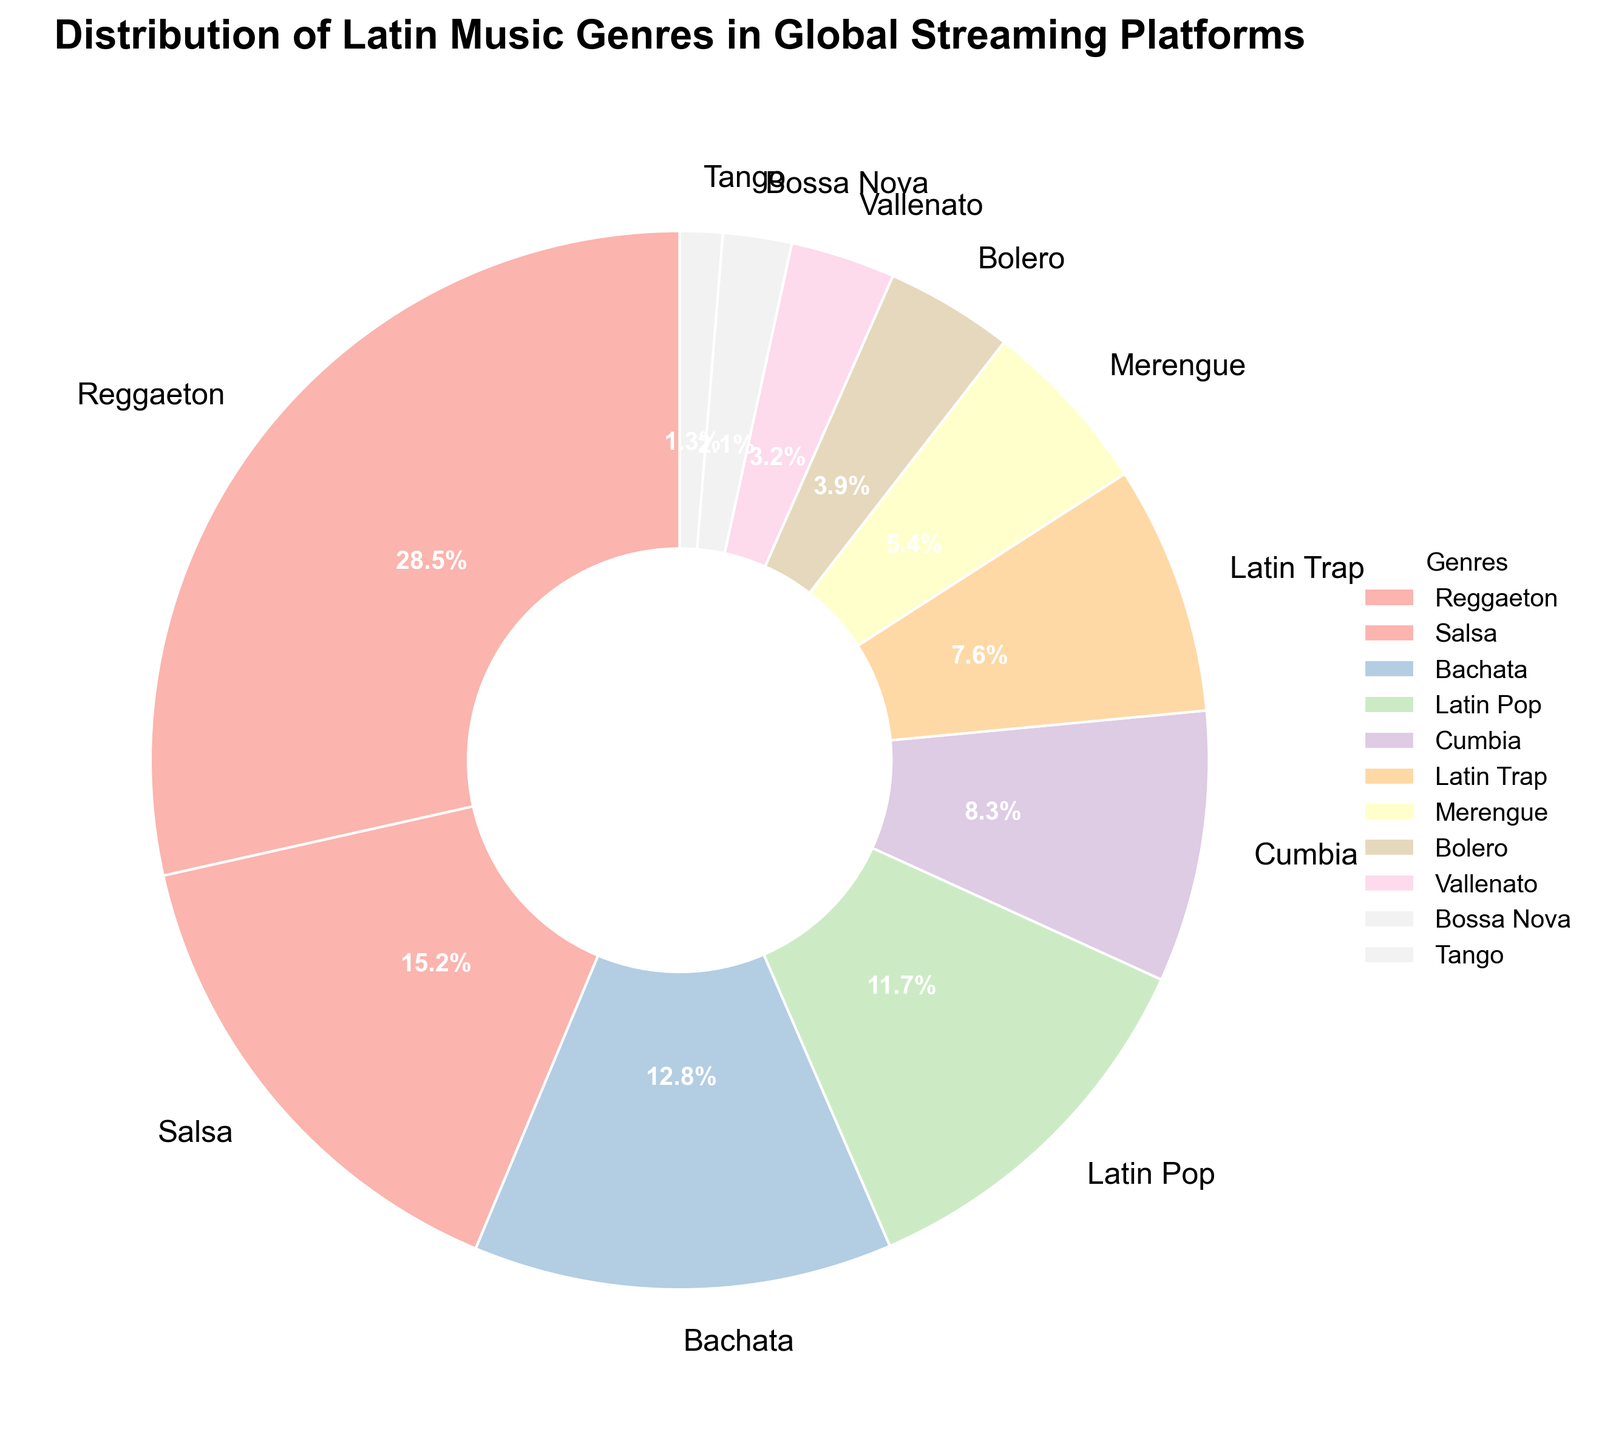Which genre has the highest percentage? By looking at the pie chart, we can see the size of each wedge. The largest wedge corresponds to Reggaeton.
Answer: Reggaeton What is the combined percentage of Salsa and Merengue? To find the combined percentage, add the percentages of Salsa and Merengue. Salsa has 15.2% and Merengue has 5.4%. Adding these together, 15.2 + 5.4 equals 20.6.
Answer: 20.6% Which genre has a slightly higher percentage: Latin Pop or Bachata? Comparing the two wedges, Bachata is slightly larger than Latin Pop. Bachata has 12.8% and Latin Pop has 11.7%. 12.8% is higher than 11.7%.
Answer: Bachata How much more percentage does Reggaeton have compared to Tango? Subtract the percentage of Tango from Reggaeton. Reggaeton has 28.5% and Tango has 1.3%. 28.5 - 1.3 equals 27.2.
Answer: 27.2% What is the total percentage of genres that have less than 5% each? Sum the percentages of all genres with less than 5%: Bolero (3.9%), Vallenato (3.2%), Bossa Nova (2.1%), and Tango (1.3%). 3.9 + 3.2 + 2.1 + 1.3 equals 10.5%.
Answer: 10.5% What are the third and fourth most popular genres? Looking at the wedges after Reggaeton and Salsa, the third and fourth are Bachata (12.8%) and Latin Pop (11.7%), respectively.
Answer: Bachata, Latin Pop Which genre between Latin Trap and Cumbia has a larger percentage, and by how much? Comparing the two wedges, Cumbia (8.3%) is larger than Latin Trap (7.6%). The difference is 8.3 - 7.6 equals 0.7.
Answer: Cumbia, 0.7% How does the combined percentage of the top three genres compare to half of the total percentage? First, find the combined percentage of the top three genres: Reggaeton (28.5%), Salsa (15.2%), and Bachata (12.8%). 28.5 + 15.2 + 12.8 equals 56.5%. Half of the total percentage is 50%. Since 56.5% is more than 50%, the combined percentage of the top three genres is higher.
Answer: Higher What is the difference between the highest and the lowest percentages? Subtract the lowest percentage (Tango with 1.3%) from the highest percentage (Reggaeton with 28.5%). 28.5 - 1.3 equals 27.2.
Answer: 27.2 Which genres make up approximately one-quarter of the total percentage? Analyzing the pie chart, one-quarter of the total percentage is 25%. Reggaeton alone is 28.5%, which is already more than 25%. Therefore, Reggaeton makes up approximately one-quarter of the total percentage by itself.
Answer: Reggaeton 